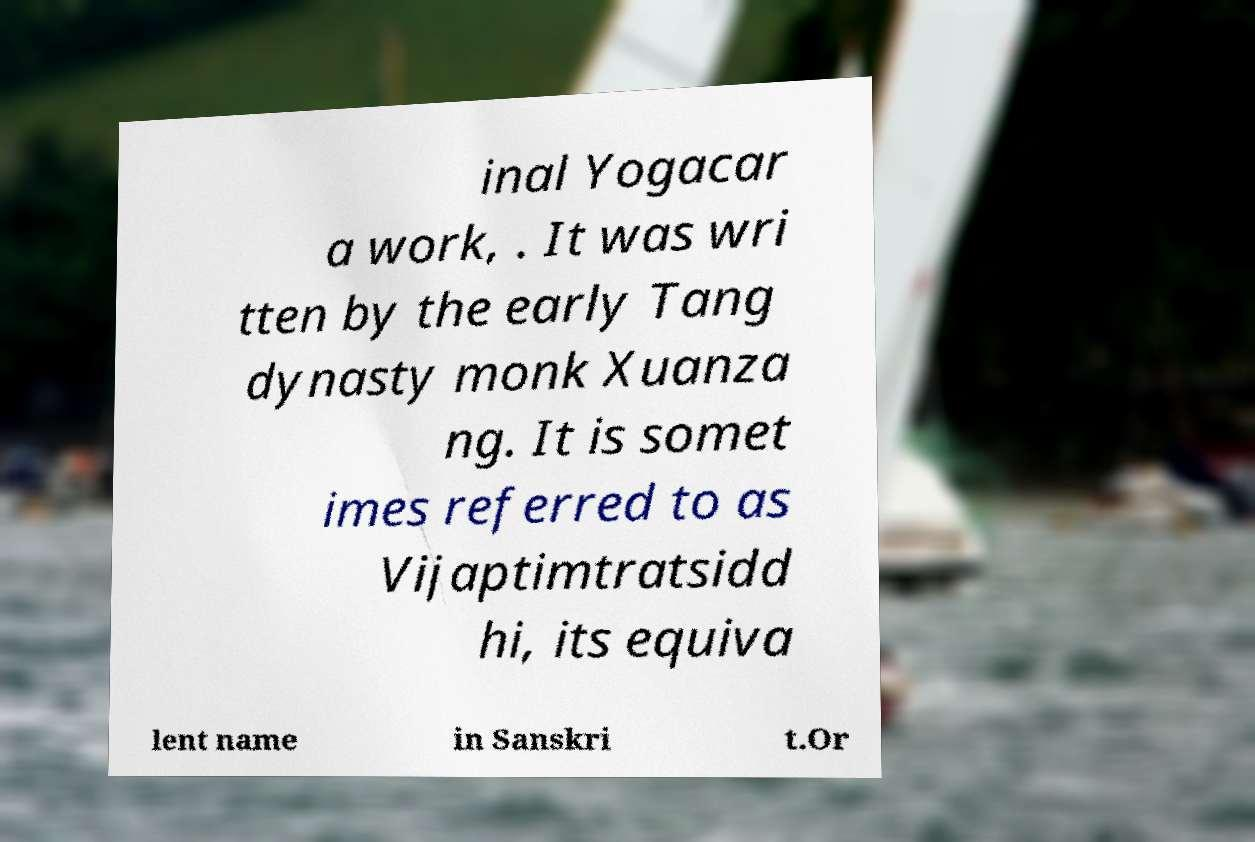Could you assist in decoding the text presented in this image and type it out clearly? inal Yogacar a work, . It was wri tten by the early Tang dynasty monk Xuanza ng. It is somet imes referred to as Vijaptimtratsidd hi, its equiva lent name in Sanskri t.Or 